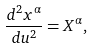<formula> <loc_0><loc_0><loc_500><loc_500>\frac { d ^ { 2 } x ^ { \alpha } } { d u ^ { 2 } } = X ^ { \alpha } ,</formula> 